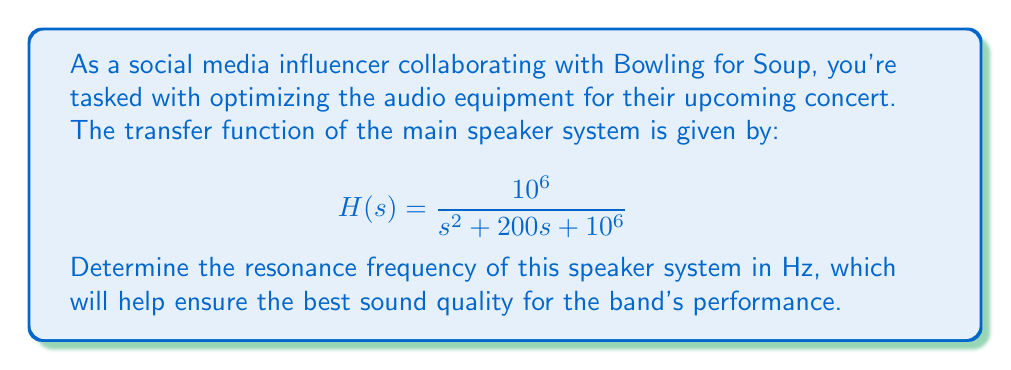Give your solution to this math problem. To find the resonance frequency, we need to follow these steps:

1) The resonance frequency occurs at the imaginary part of the complex poles of the transfer function.

2) To find the poles, we need to solve the characteristic equation:
   $$s^2 + 200s + 10^6 = 0$$

3) This is a quadratic equation of the form $as^2 + bs + c = 0$, where $a=1$, $b=200$, and $c=10^6$.

4) We can solve this using the quadratic formula: $s = \frac{-b \pm \sqrt{b^2 - 4ac}}{2a}$

5) Substituting our values:
   $$s = \frac{-200 \pm \sqrt{200^2 - 4(1)(10^6)}}{2(1)}$$

6) Simplifying:
   $$s = -100 \pm \sqrt{40000 - 4000000} = -100 \pm \sqrt{-3960000} = -100 \pm j\sqrt{3960000}$$

7) The imaginary part is $\sqrt{3960000} = 1990$.

8) This gives us the angular frequency $\omega$ in radians per second. To convert to Hz, we divide by $2\pi$:
   $$f = \frac{\omega}{2\pi} = \frac{1990}{2\pi} \approx 316.7 \text{ Hz}$$

Therefore, the resonance frequency of the speaker system is approximately 316.7 Hz.
Answer: 316.7 Hz 